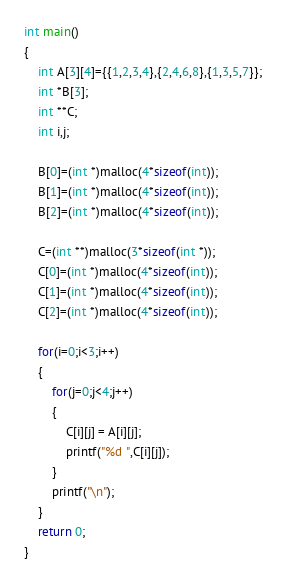<code> <loc_0><loc_0><loc_500><loc_500><_C_>int main()
{
	int A[3][4]={{1,2,3,4},{2,4,6,8},{1,3,5,7}};
    int *B[3];
    int **C;
    int i,j;
 
    B[0]=(int *)malloc(4*sizeof(int));
  	B[1]=(int *)malloc(4*sizeof(int));
  	B[2]=(int *)malloc(4*sizeof(int));
  
  	C=(int **)malloc(3*sizeof(int *));
  	C[0]=(int *)malloc(4*sizeof(int));
  	C[1]=(int *)malloc(4*sizeof(int));
  	C[2]=(int *)malloc(4*sizeof(int));
  
  	for(i=0;i<3;i++)
  	{
 		for(j=0;j<4;j++)
		{
			C[i][j] = A[i][j];
  			printf("%d ",C[i][j]);
		}
 	 	printf("\n");
  	}
   	return 0;
}
</code> 